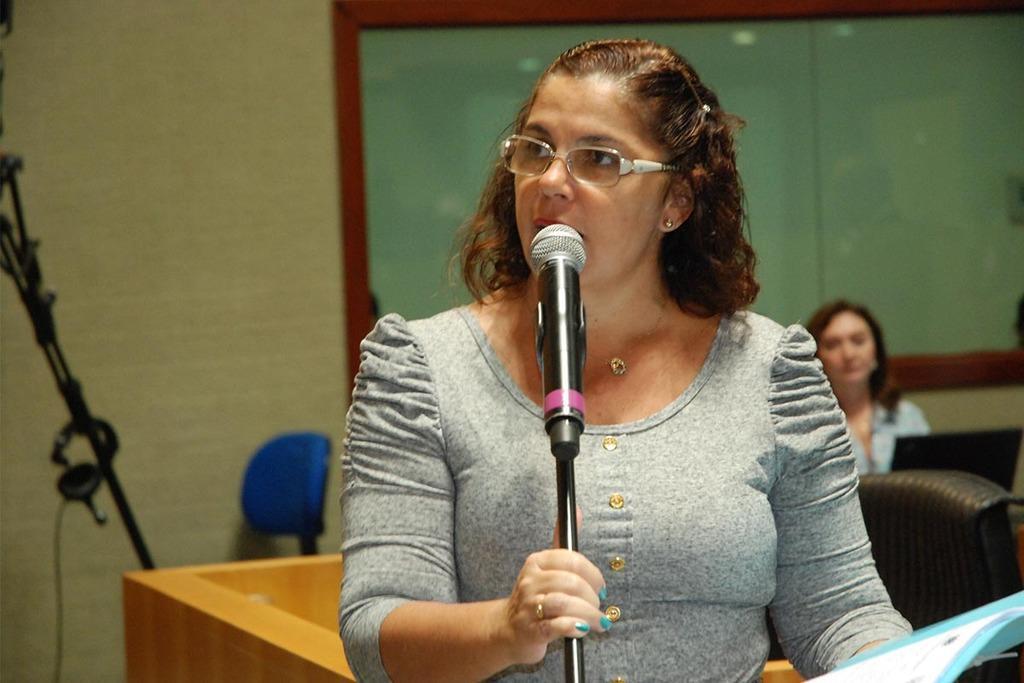How would you summarize this image in a sentence or two? In the background we can see a board, chairs, woman and a laptop. We can see a woman with a short hair wearing spectacles. She is holding a mike stand with her hand. 